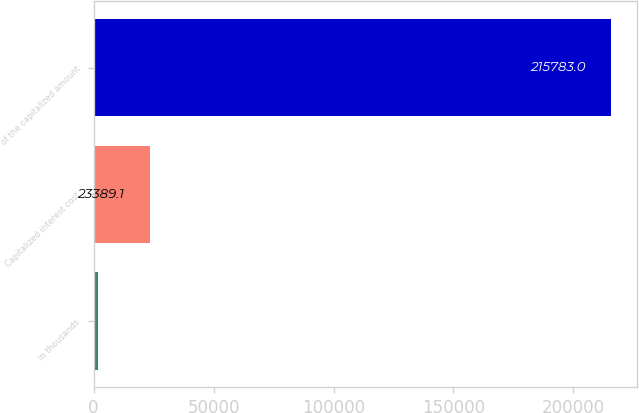Convert chart. <chart><loc_0><loc_0><loc_500><loc_500><bar_chart><fcel>in thousands<fcel>Capitalized interest cost<fcel>of the capitalized amount<nl><fcel>2012<fcel>23389.1<fcel>215783<nl></chart> 